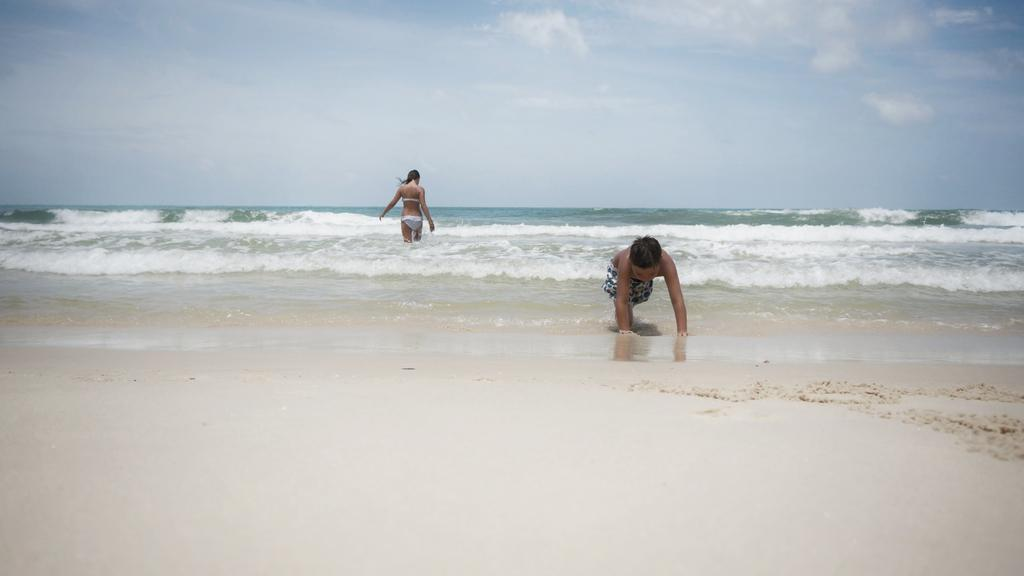Who is present in the image? There is a woman and a child in the image. What is the woman doing in the image? The woman is in water. What type of terrain can be seen in the image? There is sand in the image. What is visible in the background of the image? The sky is visible in the background of the image, and there are clouds in the sky. What type of mark can be seen on the child's forehead in the image? There is no mark visible on the child's forehead in the image. How many cherries are being held by the woman in the image? There are no cherries present in the image. Is there a frog visible in the image? There is no frog present in the image. 